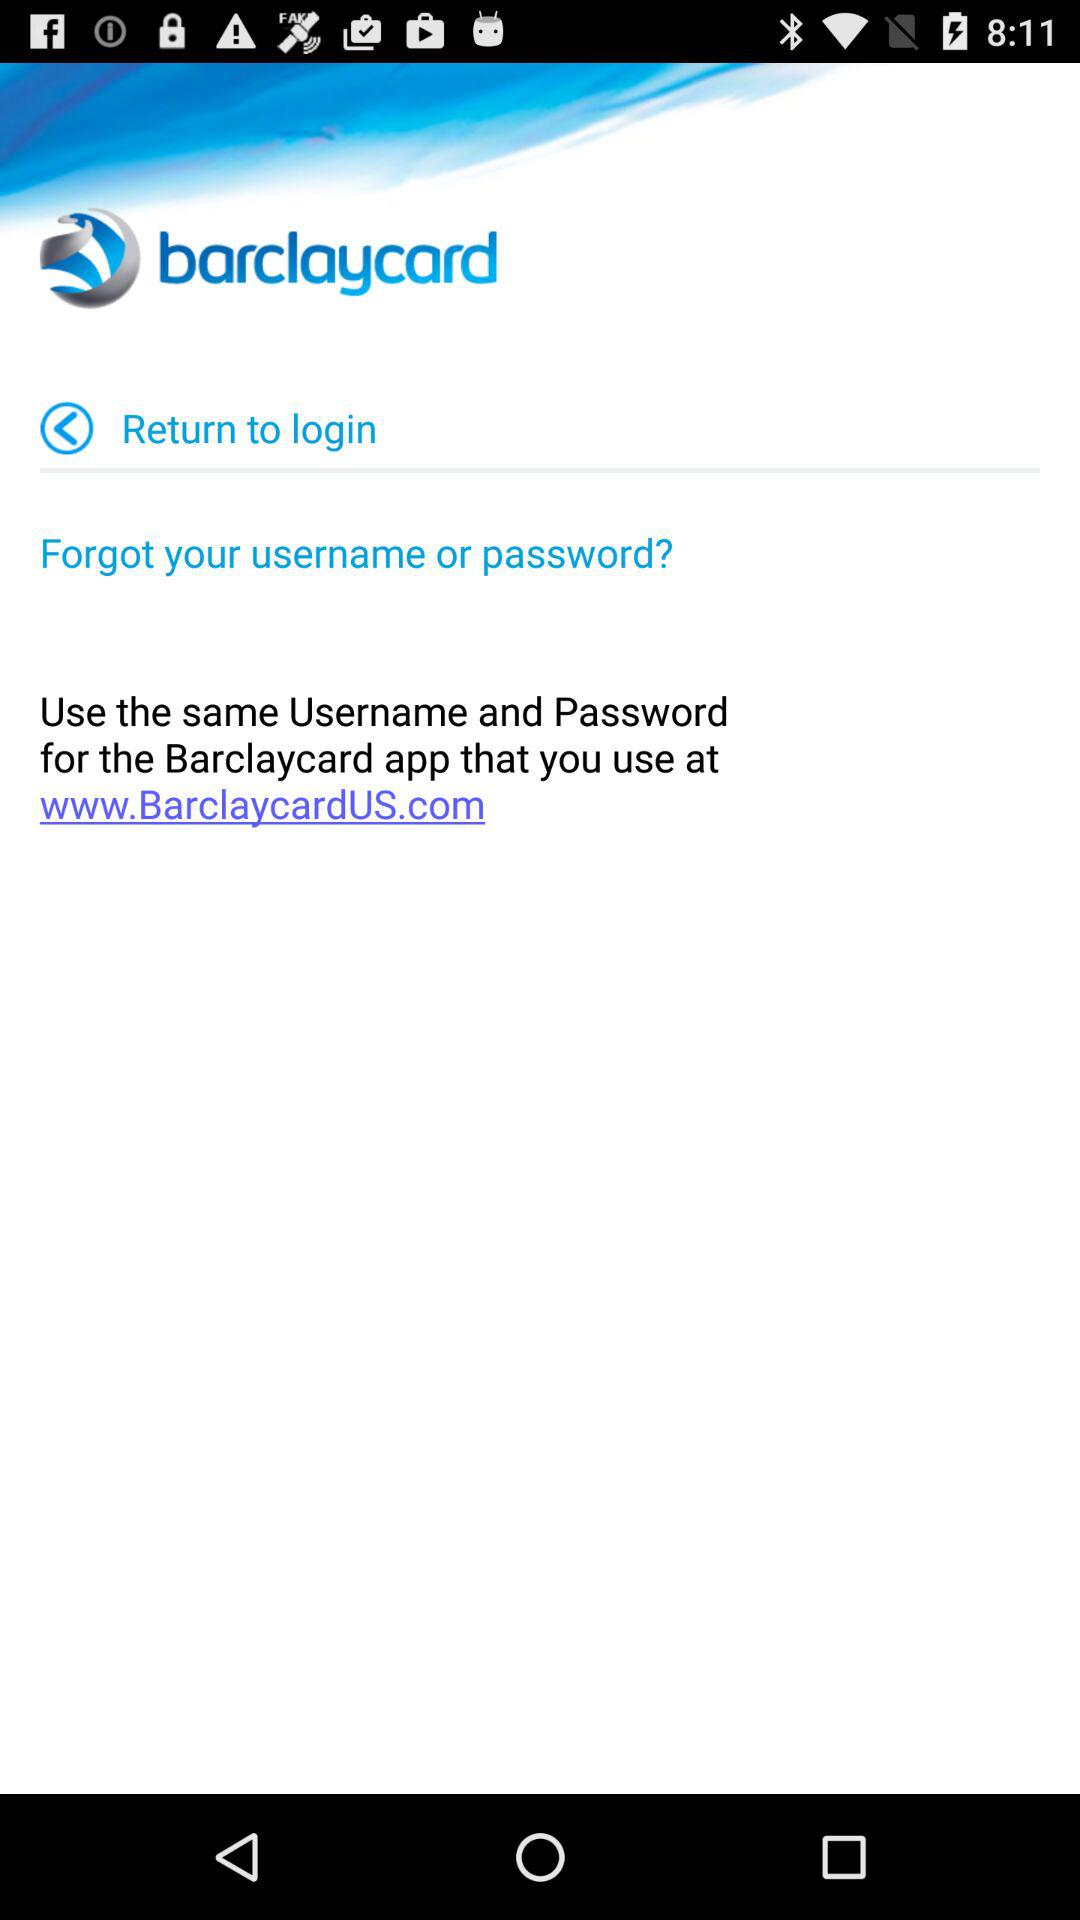What is the application name? The application name is "barclaycard". 